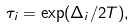Convert formula to latex. <formula><loc_0><loc_0><loc_500><loc_500>\tau _ { i } = \exp ( \Delta _ { i } / 2 T ) ,</formula> 